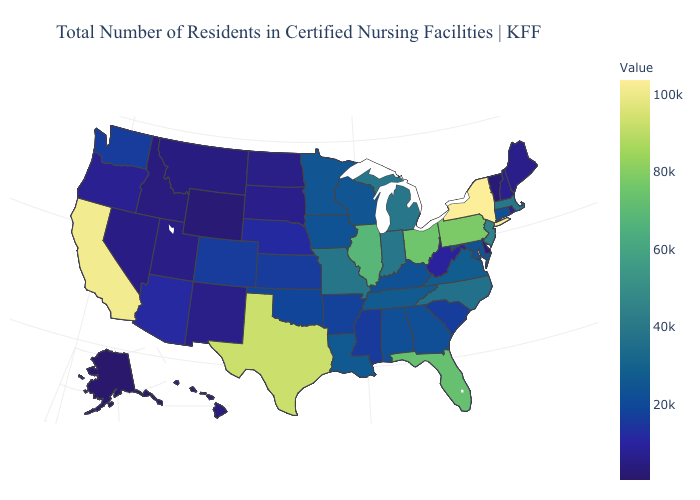Is the legend a continuous bar?
Quick response, please. Yes. Is the legend a continuous bar?
Concise answer only. Yes. Among the states that border North Dakota , does South Dakota have the highest value?
Give a very brief answer. No. Among the states that border Mississippi , which have the highest value?
Answer briefly. Tennessee. Among the states that border Connecticut , does Massachusetts have the highest value?
Answer briefly. No. Which states hav the highest value in the South?
Short answer required. Texas. 